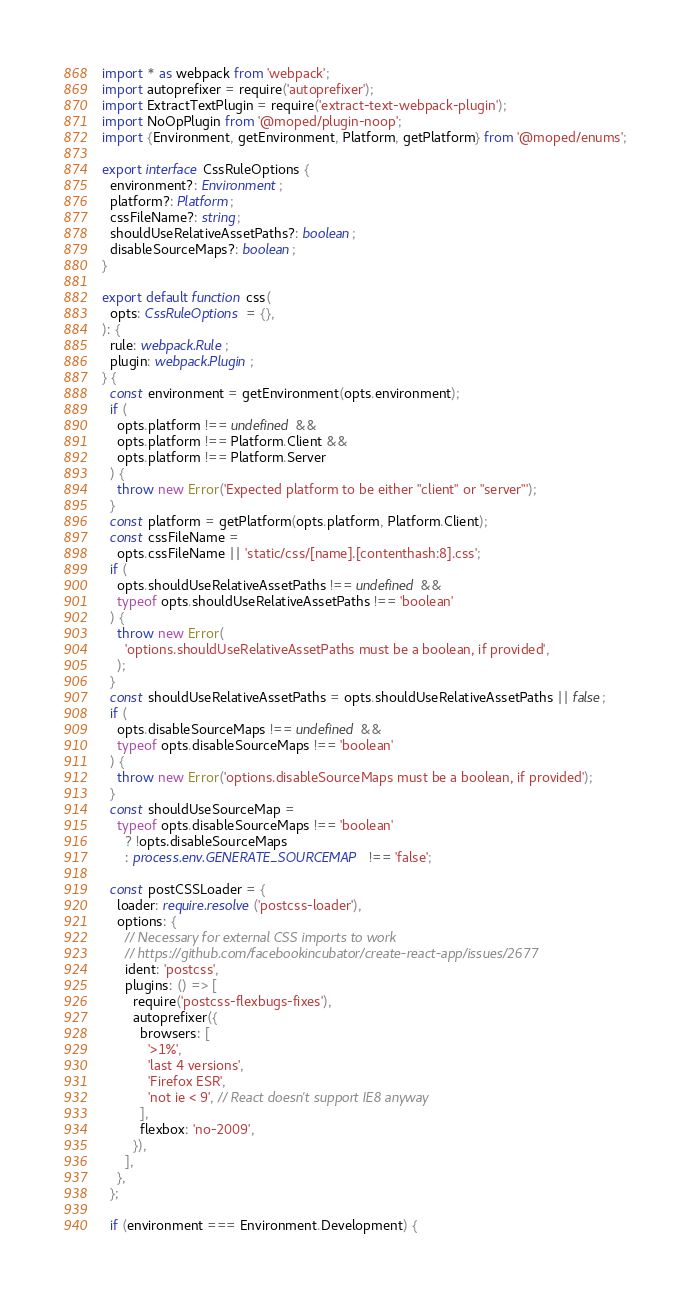Convert code to text. <code><loc_0><loc_0><loc_500><loc_500><_TypeScript_>import * as webpack from 'webpack';
import autoprefixer = require('autoprefixer');
import ExtractTextPlugin = require('extract-text-webpack-plugin');
import NoOpPlugin from '@moped/plugin-noop';
import {Environment, getEnvironment, Platform, getPlatform} from '@moped/enums';

export interface CssRuleOptions {
  environment?: Environment;
  platform?: Platform;
  cssFileName?: string;
  shouldUseRelativeAssetPaths?: boolean;
  disableSourceMaps?: boolean;
}

export default function css(
  opts: CssRuleOptions = {},
): {
  rule: webpack.Rule;
  plugin: webpack.Plugin;
} {
  const environment = getEnvironment(opts.environment);
  if (
    opts.platform !== undefined &&
    opts.platform !== Platform.Client &&
    opts.platform !== Platform.Server
  ) {
    throw new Error('Expected platform to be either "client" or "server"');
  }
  const platform = getPlatform(opts.platform, Platform.Client);
  const cssFileName =
    opts.cssFileName || 'static/css/[name].[contenthash:8].css';
  if (
    opts.shouldUseRelativeAssetPaths !== undefined &&
    typeof opts.shouldUseRelativeAssetPaths !== 'boolean'
  ) {
    throw new Error(
      'options.shouldUseRelativeAssetPaths must be a boolean, if provided',
    );
  }
  const shouldUseRelativeAssetPaths = opts.shouldUseRelativeAssetPaths || false;
  if (
    opts.disableSourceMaps !== undefined &&
    typeof opts.disableSourceMaps !== 'boolean'
  ) {
    throw new Error('options.disableSourceMaps must be a boolean, if provided');
  }
  const shouldUseSourceMap =
    typeof opts.disableSourceMaps !== 'boolean'
      ? !opts.disableSourceMaps
      : process.env.GENERATE_SOURCEMAP !== 'false';

  const postCSSLoader = {
    loader: require.resolve('postcss-loader'),
    options: {
      // Necessary for external CSS imports to work
      // https://github.com/facebookincubator/create-react-app/issues/2677
      ident: 'postcss',
      plugins: () => [
        require('postcss-flexbugs-fixes'),
        autoprefixer({
          browsers: [
            '>1%',
            'last 4 versions',
            'Firefox ESR',
            'not ie < 9', // React doesn't support IE8 anyway
          ],
          flexbox: 'no-2009',
        }),
      ],
    },
  };

  if (environment === Environment.Development) {</code> 